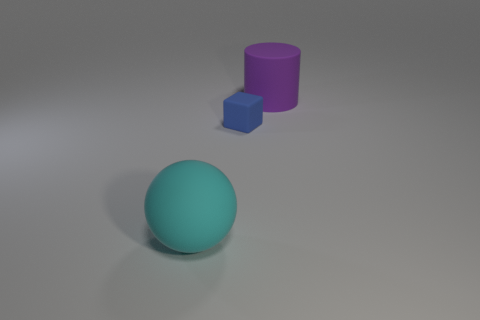Are there any other things that have the same material as the cylinder?
Ensure brevity in your answer.  Yes. How many blocks are on the left side of the big rubber thing behind the big rubber object in front of the purple cylinder?
Ensure brevity in your answer.  1. There is a thing that is both behind the large cyan matte object and left of the big purple cylinder; what is its material?
Offer a very short reply. Rubber. The large rubber cylinder is what color?
Give a very brief answer. Purple. Are there more large cyan rubber balls that are to the left of the big purple matte cylinder than small matte blocks that are on the left side of the tiny blue thing?
Offer a very short reply. Yes. The big thing to the right of the large cyan rubber ball is what color?
Offer a terse response. Purple. What number of objects are either red matte blocks or large rubber objects?
Provide a succinct answer. 2. What is the big thing left of the large rubber thing that is on the right side of the small rubber object made of?
Offer a terse response. Rubber. How many small blue rubber objects have the same shape as the purple object?
Provide a short and direct response. 0. Are there any matte cylinders that have the same color as the block?
Provide a short and direct response. No. 